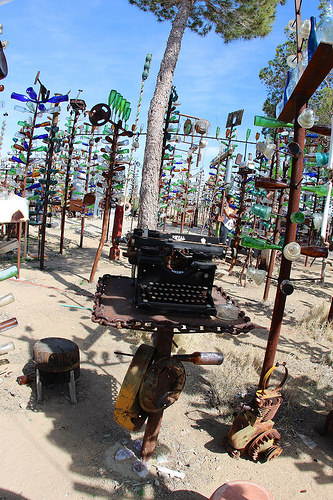<image>
Is the chair on the ground? Yes. Looking at the image, I can see the chair is positioned on top of the ground, with the ground providing support. 